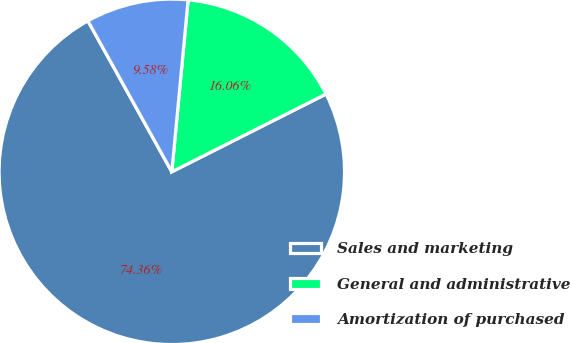<chart> <loc_0><loc_0><loc_500><loc_500><pie_chart><fcel>Sales and marketing<fcel>General and administrative<fcel>Amortization of purchased<nl><fcel>74.36%<fcel>16.06%<fcel>9.58%<nl></chart> 